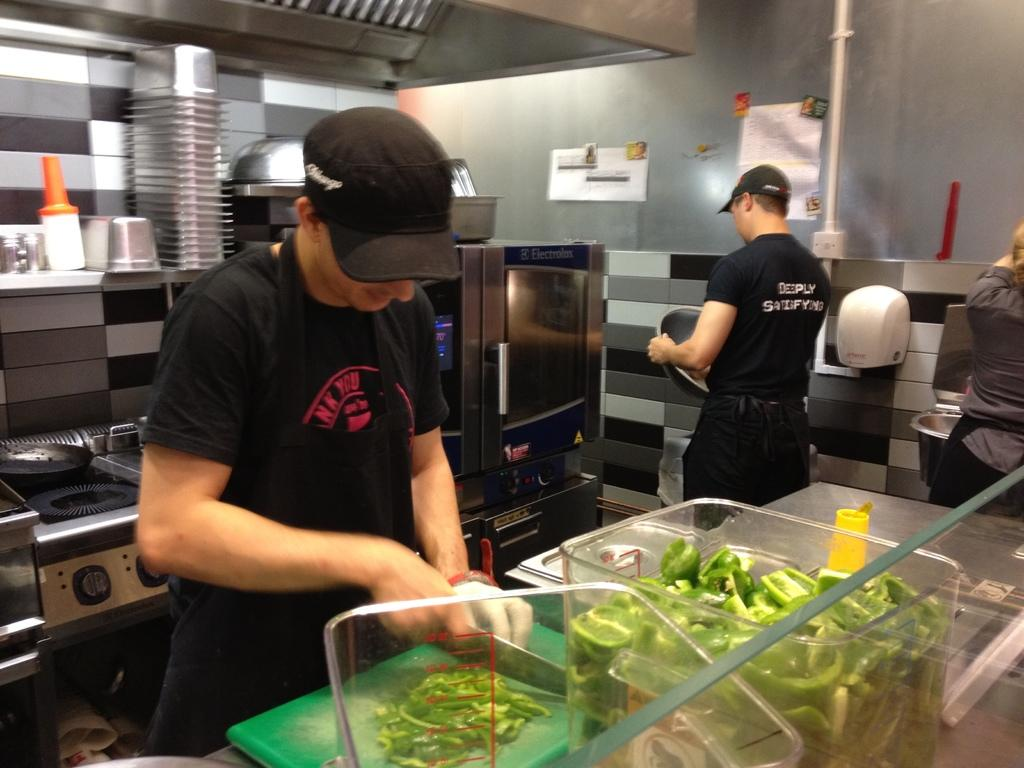<image>
Describe the image concisely. two people in a restaurant kitchen and one t shirt has letters NK YOU on it 